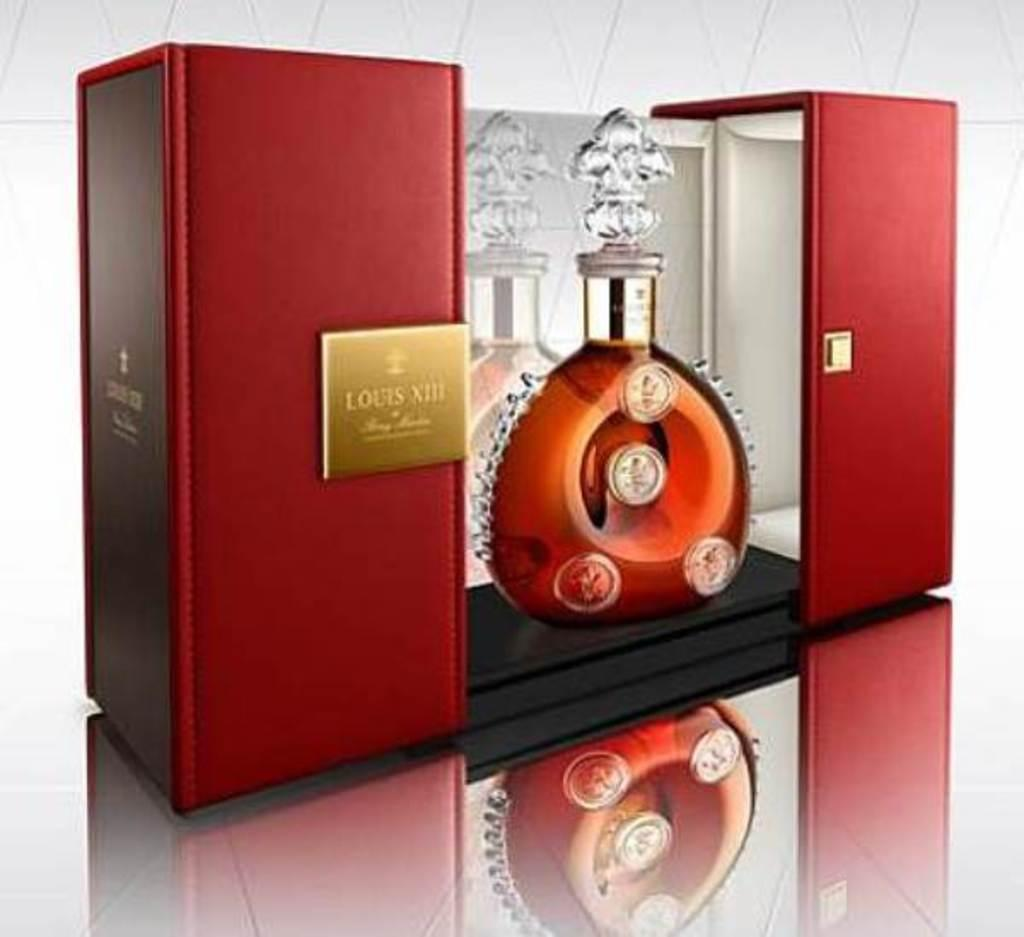What type of container is visible in the image? There is a glass bottle in the image. What color is the object in the image? There is a red color object in the image. What is the color of the background in the image? The background of the image is white in color. What type of jeans is the person wearing in the image? There is no person or jeans present in the image; it only features a glass bottle and a red object against a white background. What letter is written on the glass bottle in the image? There is no letter visible on the glass bottle in the image. 